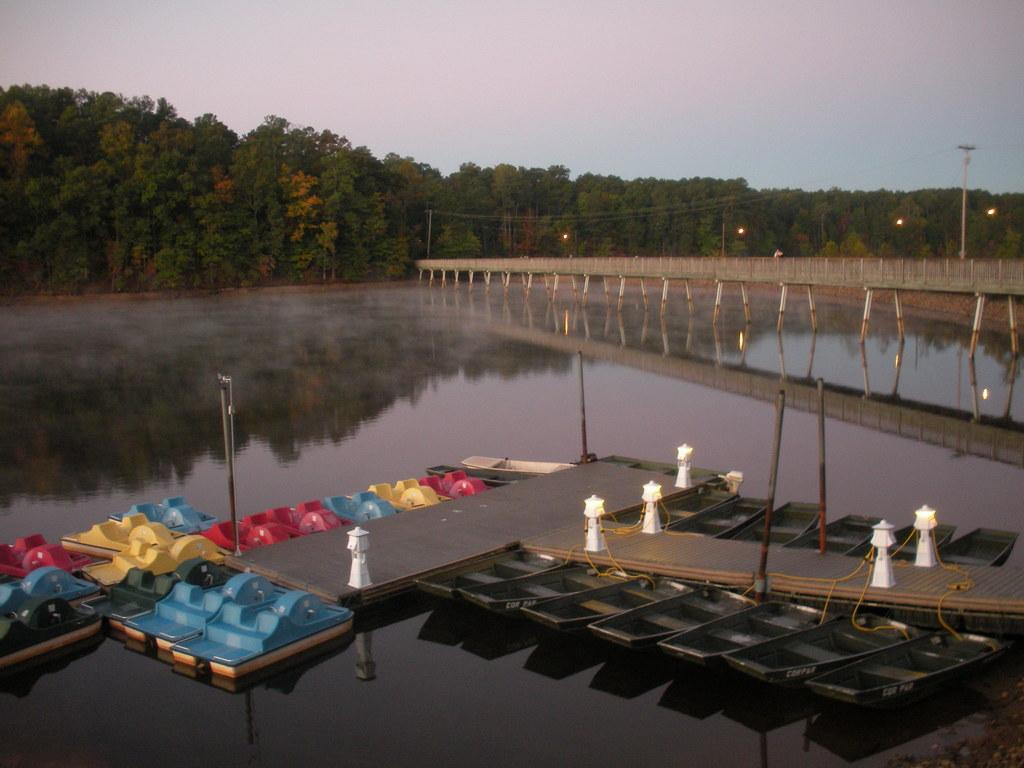What type of vehicles can be seen in the image? There are boats in the image. What colors are the boats? The boats are in various colors: black, red, green, blue, and yellow. What structures are present in the image? There are white poles, a bridge, and trees in the image. What is the color of the sky in the image? The sky is in white and blue color. What else can be seen in the water? There is water visible in the image. How many pieces of pie are being shared by the boys in the image? There are no boys or pies present in the image; it features boats, white poles, a bridge, trees, and the sky. 